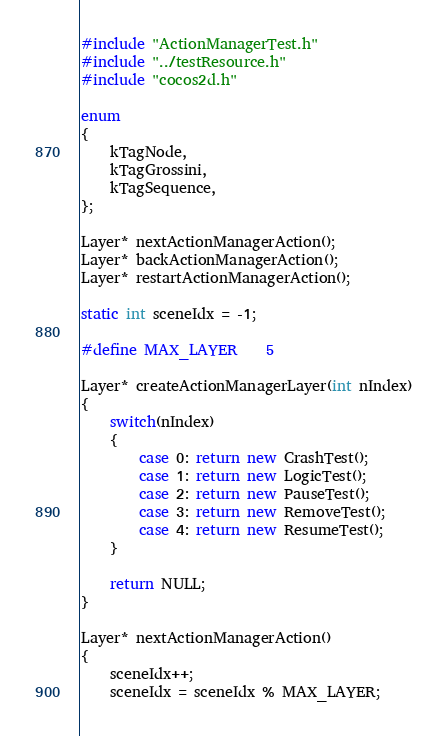Convert code to text. <code><loc_0><loc_0><loc_500><loc_500><_C++_>#include "ActionManagerTest.h"
#include "../testResource.h"
#include "cocos2d.h"

enum 
{
    kTagNode,
    kTagGrossini,
    kTagSequence,
}; 

Layer* nextActionManagerAction();
Layer* backActionManagerAction();
Layer* restartActionManagerAction();

static int sceneIdx = -1; 

#define MAX_LAYER    5

Layer* createActionManagerLayer(int nIndex)
{
    switch(nIndex)
    {
        case 0: return new CrashTest();
        case 1: return new LogicTest();
        case 2: return new PauseTest();
        case 3: return new RemoveTest();
        case 4: return new ResumeTest();
    }

    return NULL;
}

Layer* nextActionManagerAction()
{
    sceneIdx++;
    sceneIdx = sceneIdx % MAX_LAYER;
</code> 